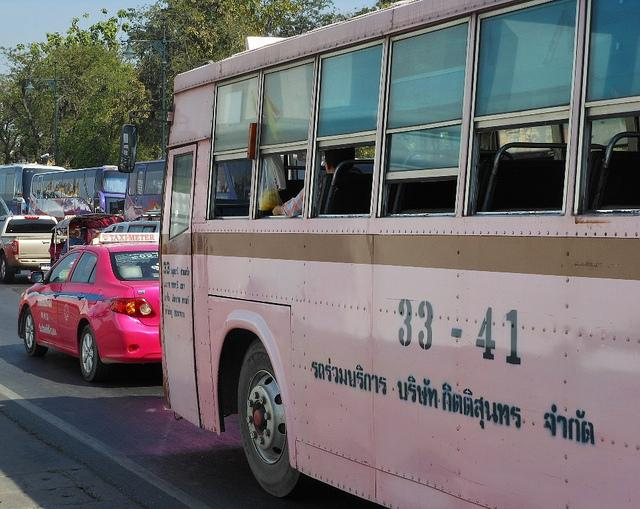What continent is this road located at?

Choices:
A) europe
B) africa
C) asia
D) australia asia 